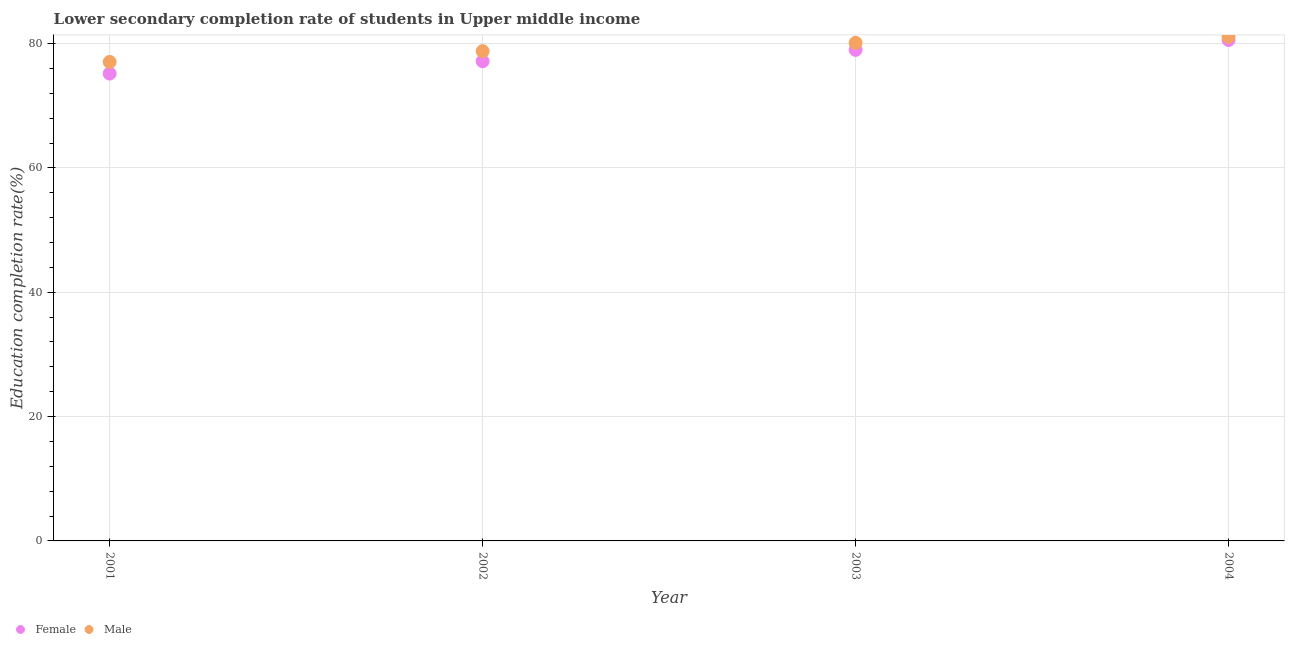What is the education completion rate of male students in 2001?
Keep it short and to the point. 77.05. Across all years, what is the maximum education completion rate of male students?
Make the answer very short. 81.11. Across all years, what is the minimum education completion rate of male students?
Ensure brevity in your answer.  77.05. In which year was the education completion rate of male students maximum?
Keep it short and to the point. 2004. In which year was the education completion rate of male students minimum?
Provide a short and direct response. 2001. What is the total education completion rate of female students in the graph?
Your response must be concise. 311.91. What is the difference between the education completion rate of female students in 2001 and that in 2003?
Your answer should be very brief. -3.81. What is the difference between the education completion rate of male students in 2003 and the education completion rate of female students in 2001?
Ensure brevity in your answer.  4.95. What is the average education completion rate of male students per year?
Your response must be concise. 79.27. In the year 2001, what is the difference between the education completion rate of male students and education completion rate of female students?
Offer a very short reply. 1.87. What is the ratio of the education completion rate of female students in 2001 to that in 2003?
Your answer should be very brief. 0.95. Is the education completion rate of male students in 2001 less than that in 2004?
Provide a short and direct response. Yes. What is the difference between the highest and the second highest education completion rate of male students?
Your response must be concise. 0.98. What is the difference between the highest and the lowest education completion rate of male students?
Keep it short and to the point. 4.06. Is the education completion rate of female students strictly greater than the education completion rate of male students over the years?
Make the answer very short. No. How many dotlines are there?
Your response must be concise. 2. What is the difference between two consecutive major ticks on the Y-axis?
Your answer should be compact. 20. Are the values on the major ticks of Y-axis written in scientific E-notation?
Your answer should be very brief. No. Does the graph contain any zero values?
Your answer should be compact. No. Does the graph contain grids?
Provide a short and direct response. Yes. Where does the legend appear in the graph?
Your response must be concise. Bottom left. How many legend labels are there?
Make the answer very short. 2. What is the title of the graph?
Make the answer very short. Lower secondary completion rate of students in Upper middle income. Does "Urban agglomerations" appear as one of the legend labels in the graph?
Make the answer very short. No. What is the label or title of the X-axis?
Offer a terse response. Year. What is the label or title of the Y-axis?
Ensure brevity in your answer.  Education completion rate(%). What is the Education completion rate(%) in Female in 2001?
Give a very brief answer. 75.18. What is the Education completion rate(%) in Male in 2001?
Offer a terse response. 77.05. What is the Education completion rate(%) of Female in 2002?
Offer a very short reply. 77.17. What is the Education completion rate(%) in Male in 2002?
Ensure brevity in your answer.  78.78. What is the Education completion rate(%) in Female in 2003?
Keep it short and to the point. 78.99. What is the Education completion rate(%) of Male in 2003?
Give a very brief answer. 80.13. What is the Education completion rate(%) of Female in 2004?
Your answer should be compact. 80.57. What is the Education completion rate(%) of Male in 2004?
Your response must be concise. 81.11. Across all years, what is the maximum Education completion rate(%) in Female?
Your answer should be compact. 80.57. Across all years, what is the maximum Education completion rate(%) in Male?
Make the answer very short. 81.11. Across all years, what is the minimum Education completion rate(%) of Female?
Your answer should be compact. 75.18. Across all years, what is the minimum Education completion rate(%) in Male?
Provide a short and direct response. 77.05. What is the total Education completion rate(%) in Female in the graph?
Your response must be concise. 311.91. What is the total Education completion rate(%) of Male in the graph?
Keep it short and to the point. 317.06. What is the difference between the Education completion rate(%) in Female in 2001 and that in 2002?
Your response must be concise. -1.99. What is the difference between the Education completion rate(%) of Male in 2001 and that in 2002?
Give a very brief answer. -1.73. What is the difference between the Education completion rate(%) in Female in 2001 and that in 2003?
Give a very brief answer. -3.81. What is the difference between the Education completion rate(%) of Male in 2001 and that in 2003?
Make the answer very short. -3.08. What is the difference between the Education completion rate(%) in Female in 2001 and that in 2004?
Your answer should be compact. -5.39. What is the difference between the Education completion rate(%) of Male in 2001 and that in 2004?
Give a very brief answer. -4.06. What is the difference between the Education completion rate(%) of Female in 2002 and that in 2003?
Provide a short and direct response. -1.82. What is the difference between the Education completion rate(%) in Male in 2002 and that in 2003?
Offer a terse response. -1.34. What is the difference between the Education completion rate(%) of Female in 2002 and that in 2004?
Make the answer very short. -3.41. What is the difference between the Education completion rate(%) in Male in 2002 and that in 2004?
Offer a very short reply. -2.32. What is the difference between the Education completion rate(%) in Female in 2003 and that in 2004?
Your response must be concise. -1.59. What is the difference between the Education completion rate(%) of Male in 2003 and that in 2004?
Ensure brevity in your answer.  -0.98. What is the difference between the Education completion rate(%) of Female in 2001 and the Education completion rate(%) of Male in 2002?
Ensure brevity in your answer.  -3.6. What is the difference between the Education completion rate(%) in Female in 2001 and the Education completion rate(%) in Male in 2003?
Offer a very short reply. -4.95. What is the difference between the Education completion rate(%) of Female in 2001 and the Education completion rate(%) of Male in 2004?
Your answer should be very brief. -5.92. What is the difference between the Education completion rate(%) in Female in 2002 and the Education completion rate(%) in Male in 2003?
Your answer should be compact. -2.96. What is the difference between the Education completion rate(%) of Female in 2002 and the Education completion rate(%) of Male in 2004?
Keep it short and to the point. -3.94. What is the difference between the Education completion rate(%) in Female in 2003 and the Education completion rate(%) in Male in 2004?
Give a very brief answer. -2.12. What is the average Education completion rate(%) of Female per year?
Make the answer very short. 77.98. What is the average Education completion rate(%) of Male per year?
Give a very brief answer. 79.27. In the year 2001, what is the difference between the Education completion rate(%) in Female and Education completion rate(%) in Male?
Ensure brevity in your answer.  -1.87. In the year 2002, what is the difference between the Education completion rate(%) in Female and Education completion rate(%) in Male?
Ensure brevity in your answer.  -1.61. In the year 2003, what is the difference between the Education completion rate(%) in Female and Education completion rate(%) in Male?
Keep it short and to the point. -1.14. In the year 2004, what is the difference between the Education completion rate(%) in Female and Education completion rate(%) in Male?
Keep it short and to the point. -0.53. What is the ratio of the Education completion rate(%) in Female in 2001 to that in 2002?
Offer a terse response. 0.97. What is the ratio of the Education completion rate(%) in Female in 2001 to that in 2003?
Provide a short and direct response. 0.95. What is the ratio of the Education completion rate(%) of Male in 2001 to that in 2003?
Offer a terse response. 0.96. What is the ratio of the Education completion rate(%) in Female in 2001 to that in 2004?
Your response must be concise. 0.93. What is the ratio of the Education completion rate(%) in Male in 2001 to that in 2004?
Provide a succinct answer. 0.95. What is the ratio of the Education completion rate(%) in Male in 2002 to that in 2003?
Provide a short and direct response. 0.98. What is the ratio of the Education completion rate(%) of Female in 2002 to that in 2004?
Provide a short and direct response. 0.96. What is the ratio of the Education completion rate(%) in Male in 2002 to that in 2004?
Ensure brevity in your answer.  0.97. What is the ratio of the Education completion rate(%) of Female in 2003 to that in 2004?
Your answer should be compact. 0.98. What is the ratio of the Education completion rate(%) of Male in 2003 to that in 2004?
Your answer should be very brief. 0.99. What is the difference between the highest and the second highest Education completion rate(%) of Female?
Provide a succinct answer. 1.59. What is the difference between the highest and the second highest Education completion rate(%) of Male?
Offer a very short reply. 0.98. What is the difference between the highest and the lowest Education completion rate(%) of Female?
Provide a succinct answer. 5.39. What is the difference between the highest and the lowest Education completion rate(%) in Male?
Offer a very short reply. 4.06. 